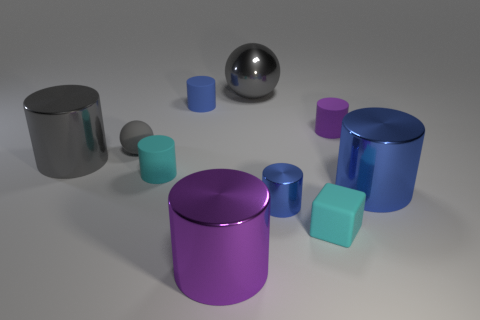Are the purple thing that is to the right of the large gray metallic ball and the small cube made of the same material?
Offer a terse response. Yes. There is a gray metal object on the left side of the gray shiny thing to the right of the large gray cylinder; how big is it?
Your answer should be compact. Large. The small cylinder that is both on the left side of the cyan matte cube and right of the large shiny sphere is what color?
Keep it short and to the point. Blue. There is a blue cylinder that is the same size as the gray shiny cylinder; what material is it?
Your answer should be very brief. Metal. How many other objects are there of the same material as the tiny gray sphere?
Provide a short and direct response. 4. Is the color of the big cylinder that is on the right side of the large gray ball the same as the ball that is to the left of the big shiny sphere?
Make the answer very short. No. The big gray object to the right of the large gray object on the left side of the blue rubber cylinder is what shape?
Give a very brief answer. Sphere. What number of other things are there of the same color as the large sphere?
Provide a succinct answer. 2. Does the small blue object that is in front of the big gray cylinder have the same material as the purple thing that is behind the block?
Keep it short and to the point. No. There is a matte cylinder behind the purple matte object; how big is it?
Give a very brief answer. Small. 